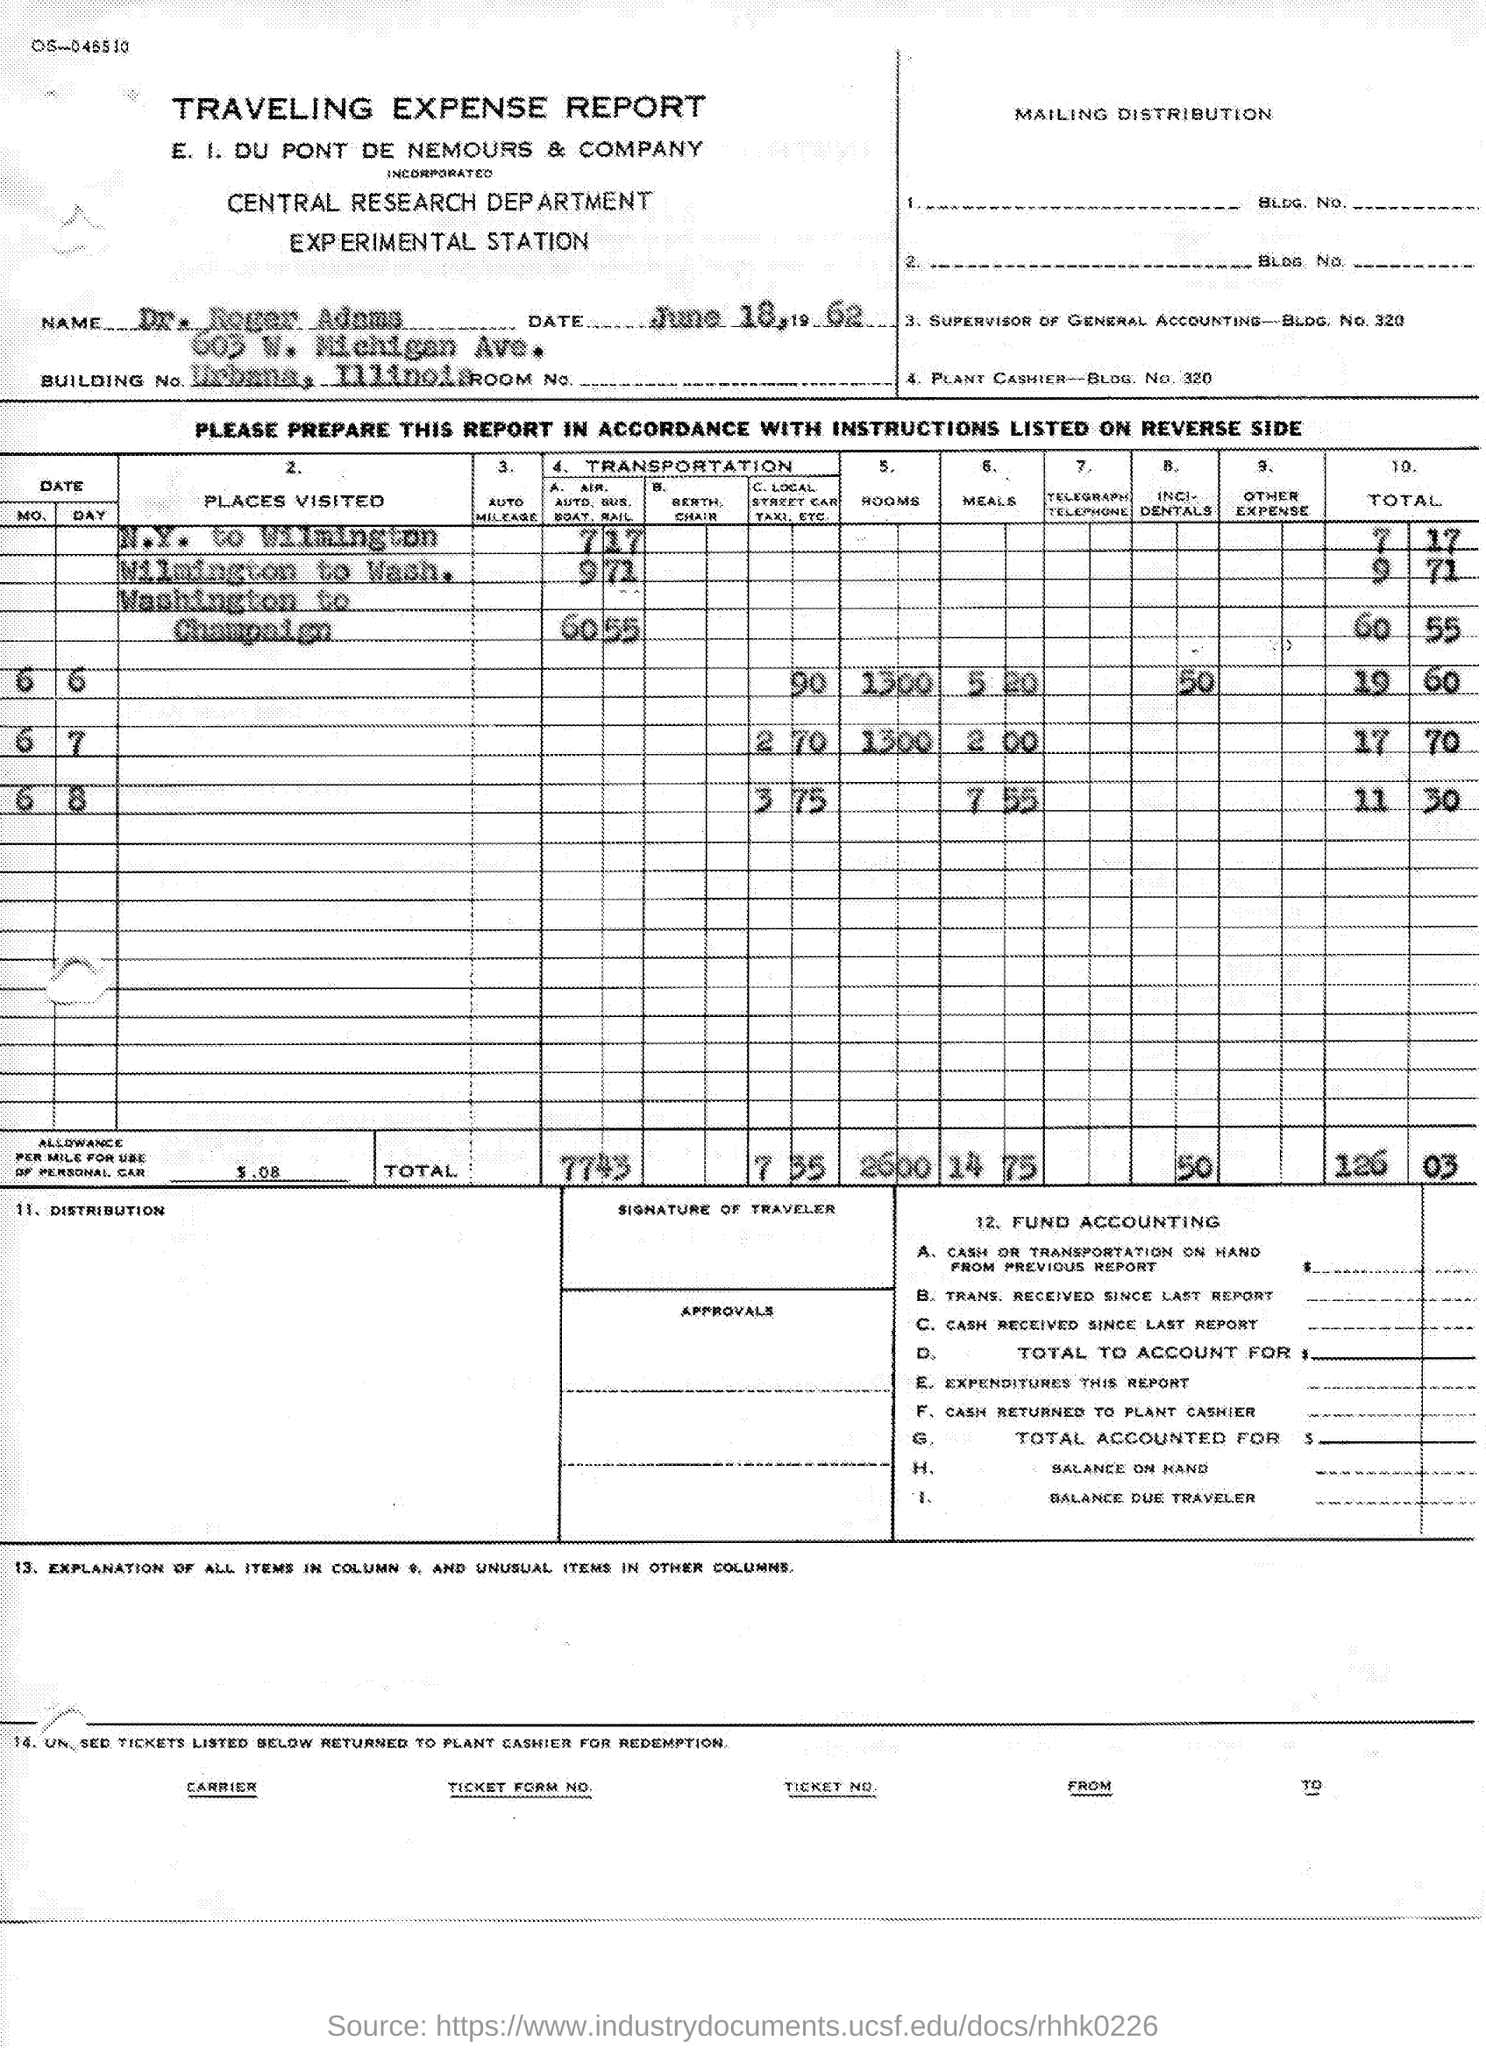What is the Name?
Offer a terse response. Dr. Roger Adams. What is the Date?
Ensure brevity in your answer.  June 18, 1962. What is the Title of the Document?
Ensure brevity in your answer.  Traveling Expense Report. 